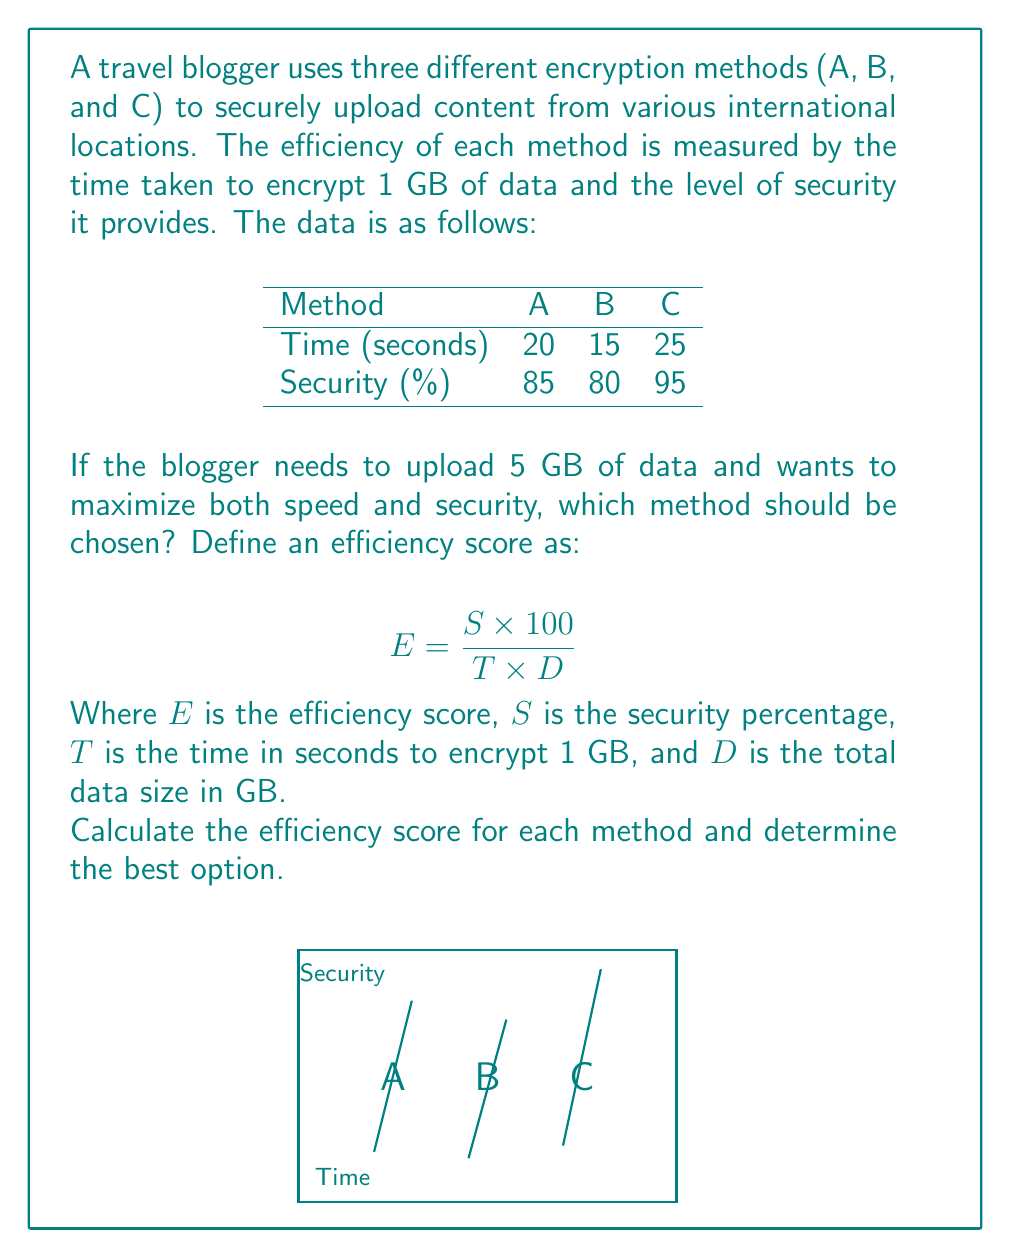Give your solution to this math problem. Let's calculate the efficiency score for each method using the given formula:

$$ E = \frac{S \times 100}{T \times D} $$

Where:
$S$ = security percentage
$T$ = time in seconds to encrypt 1 GB
$D$ = total data size in GB (5 GB for all methods)

For Method A:
$$ E_A = \frac{85 \times 100}{20 \times 5} = \frac{8500}{100} = 85 $$

For Method B:
$$ E_B = \frac{80 \times 100}{15 \times 5} = \frac{8000}{75} \approx 106.67 $$

For Method C:
$$ E_C = \frac{95 \times 100}{25 \times 5} = \frac{9500}{125} = 76 $$

Comparing the efficiency scores:
Method A: 85
Method B: 106.67
Method C: 76

Method B has the highest efficiency score, balancing speed and security best for the given scenario.
Answer: Method B (Efficiency score: 106.67) 